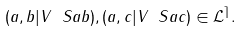<formula> <loc_0><loc_0><loc_500><loc_500>( a , b | V \ S a b ) , ( a , c | V \ S a c ) \in \mathcal { L } ^ { \rceil } .</formula> 